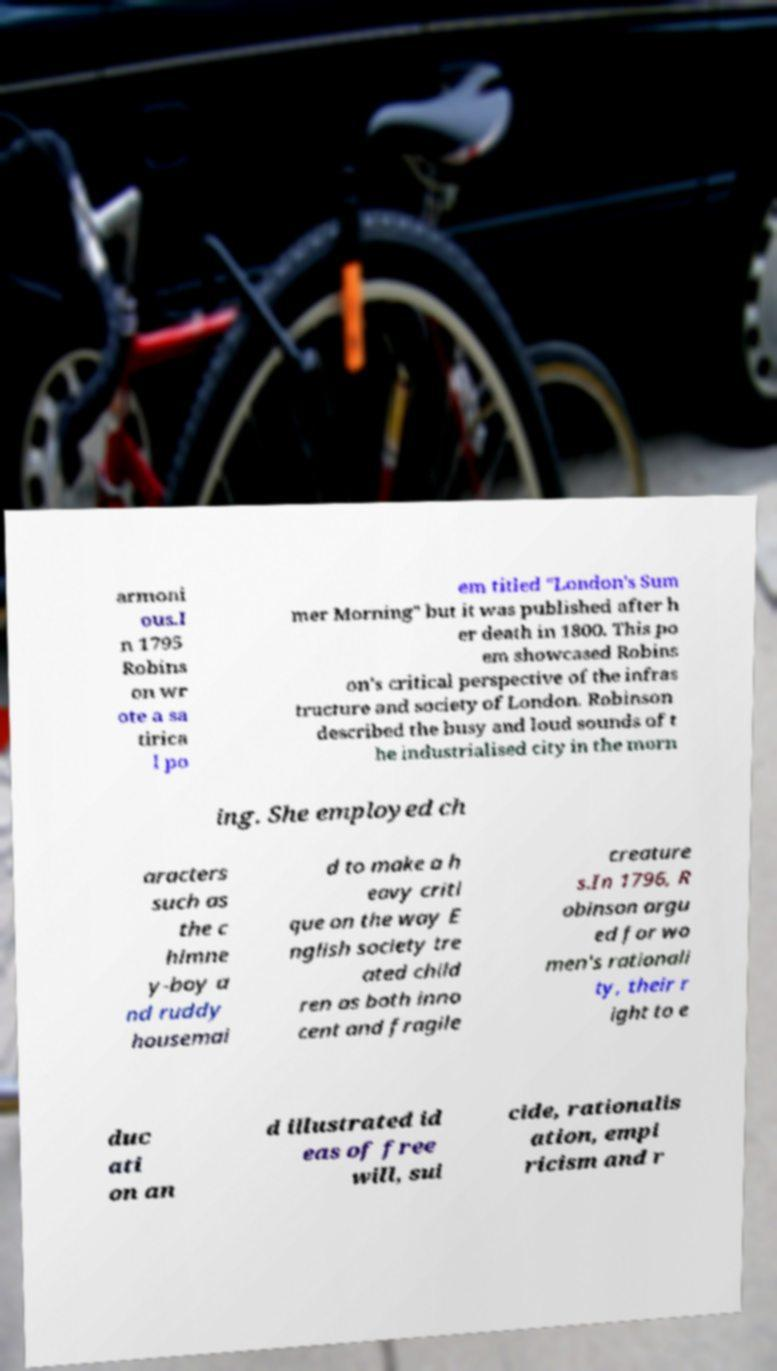Please identify and transcribe the text found in this image. armoni ous.I n 1795 Robins on wr ote a sa tirica l po em titled "London's Sum mer Morning" but it was published after h er death in 1800. This po em showcased Robins on's critical perspective of the infras tructure and society of London. Robinson described the busy and loud sounds of t he industrialised city in the morn ing. She employed ch aracters such as the c himne y-boy a nd ruddy housemai d to make a h eavy criti que on the way E nglish society tre ated child ren as both inno cent and fragile creature s.In 1796, R obinson argu ed for wo men's rationali ty, their r ight to e duc ati on an d illustrated id eas of free will, sui cide, rationalis ation, empi ricism and r 